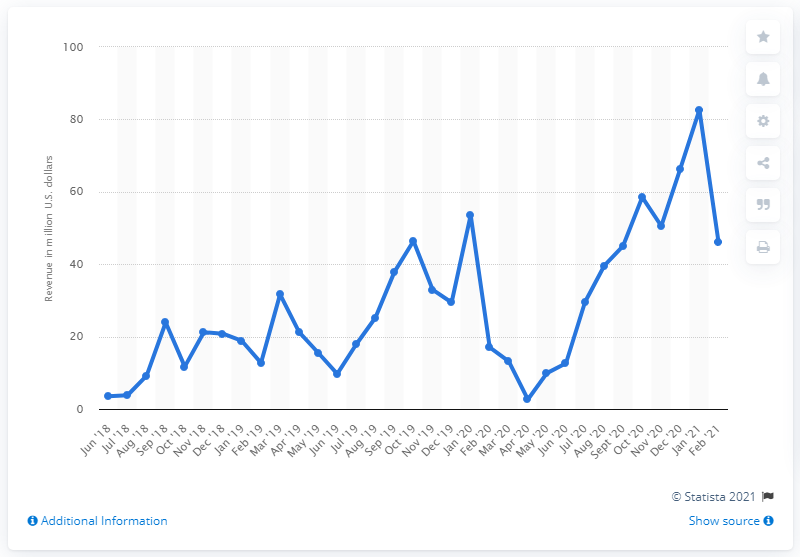Outline some significant characteristics in this image. In February 2021, New Jersey generated $46.21 million from sports betting. 